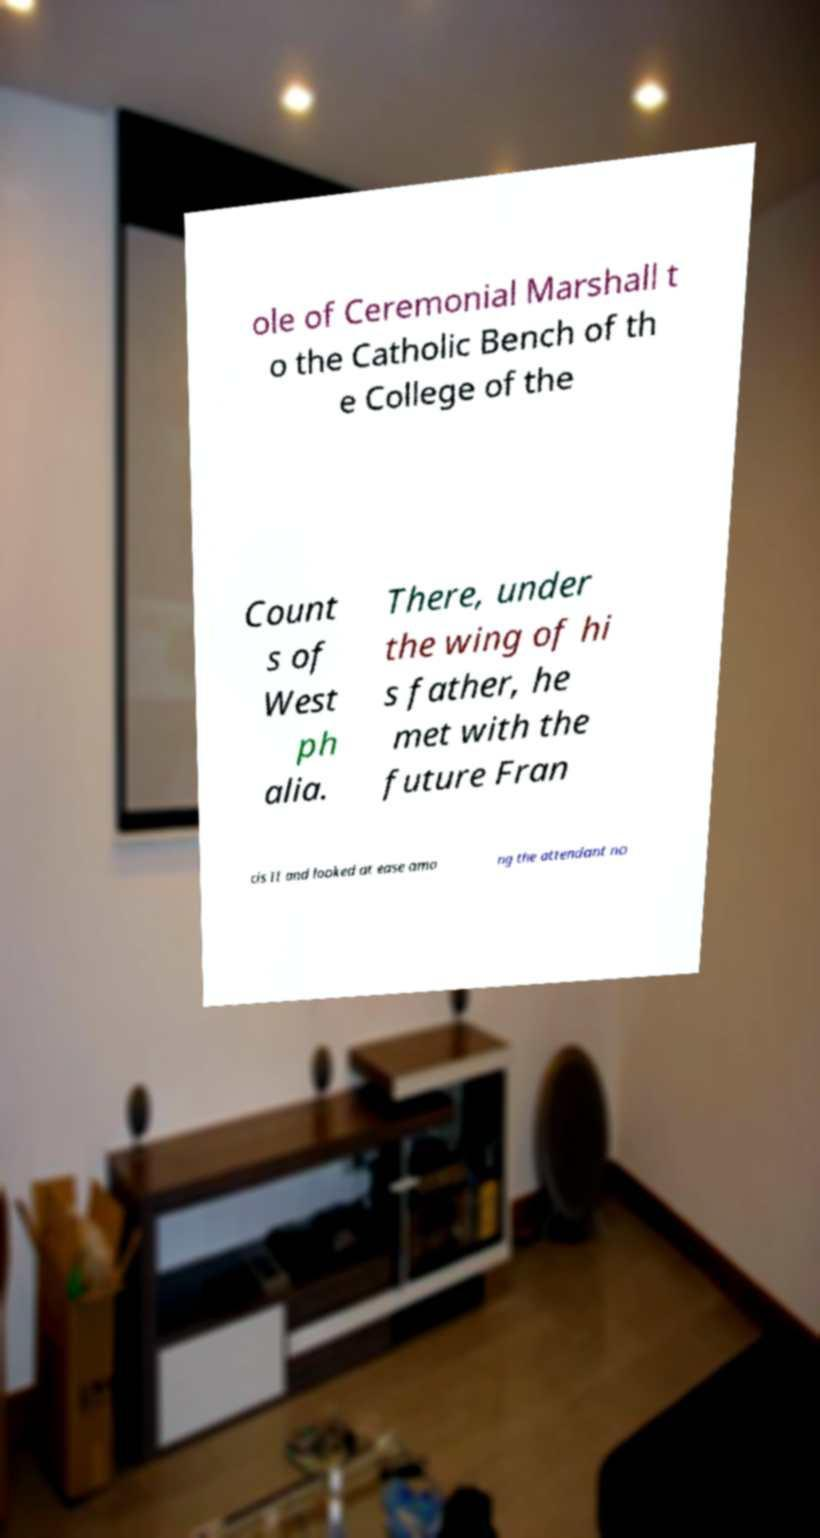Could you assist in decoding the text presented in this image and type it out clearly? ole of Ceremonial Marshall t o the Catholic Bench of th e College of the Count s of West ph alia. There, under the wing of hi s father, he met with the future Fran cis II and looked at ease amo ng the attendant no 